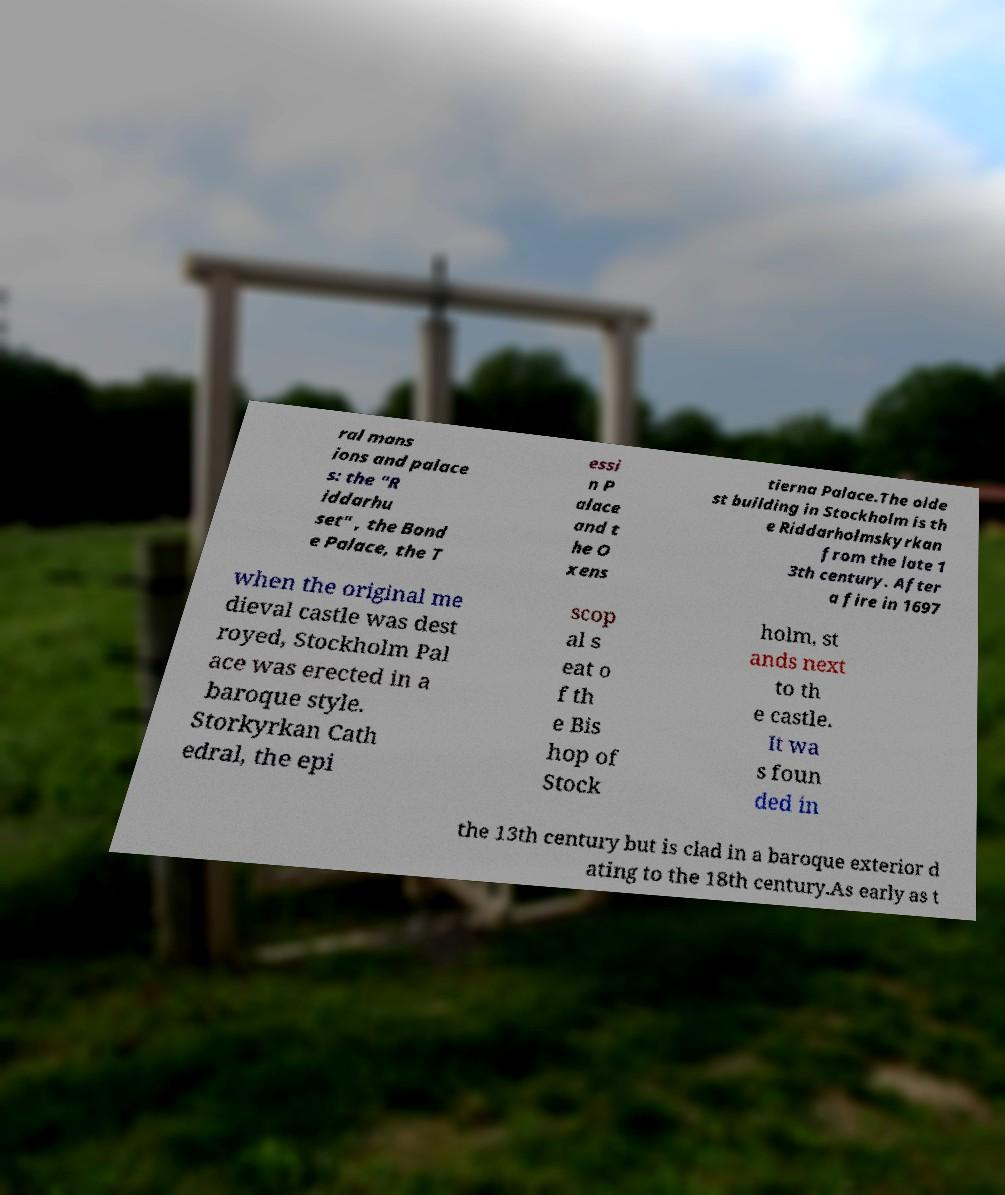There's text embedded in this image that I need extracted. Can you transcribe it verbatim? ral mans ions and palace s: the "R iddarhu set" , the Bond e Palace, the T essi n P alace and t he O xens tierna Palace.The olde st building in Stockholm is th e Riddarholmskyrkan from the late 1 3th century. After a fire in 1697 when the original me dieval castle was dest royed, Stockholm Pal ace was erected in a baroque style. Storkyrkan Cath edral, the epi scop al s eat o f th e Bis hop of Stock holm, st ands next to th e castle. It wa s foun ded in the 13th century but is clad in a baroque exterior d ating to the 18th century.As early as t 